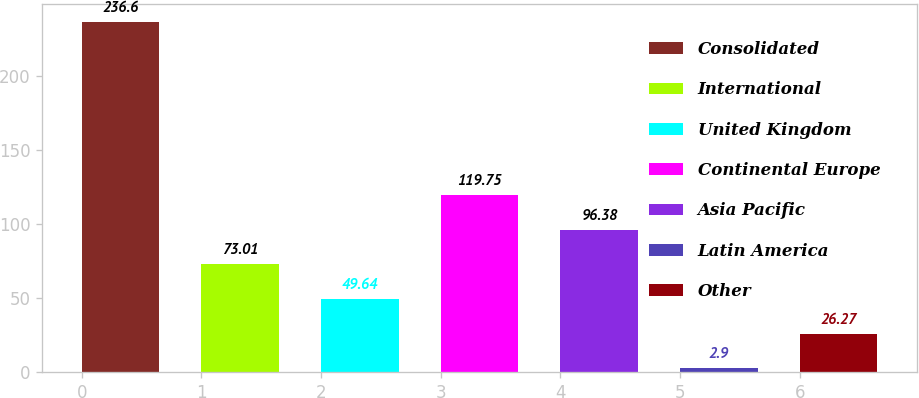<chart> <loc_0><loc_0><loc_500><loc_500><bar_chart><fcel>Consolidated<fcel>International<fcel>United Kingdom<fcel>Continental Europe<fcel>Asia Pacific<fcel>Latin America<fcel>Other<nl><fcel>236.6<fcel>73.01<fcel>49.64<fcel>119.75<fcel>96.38<fcel>2.9<fcel>26.27<nl></chart> 